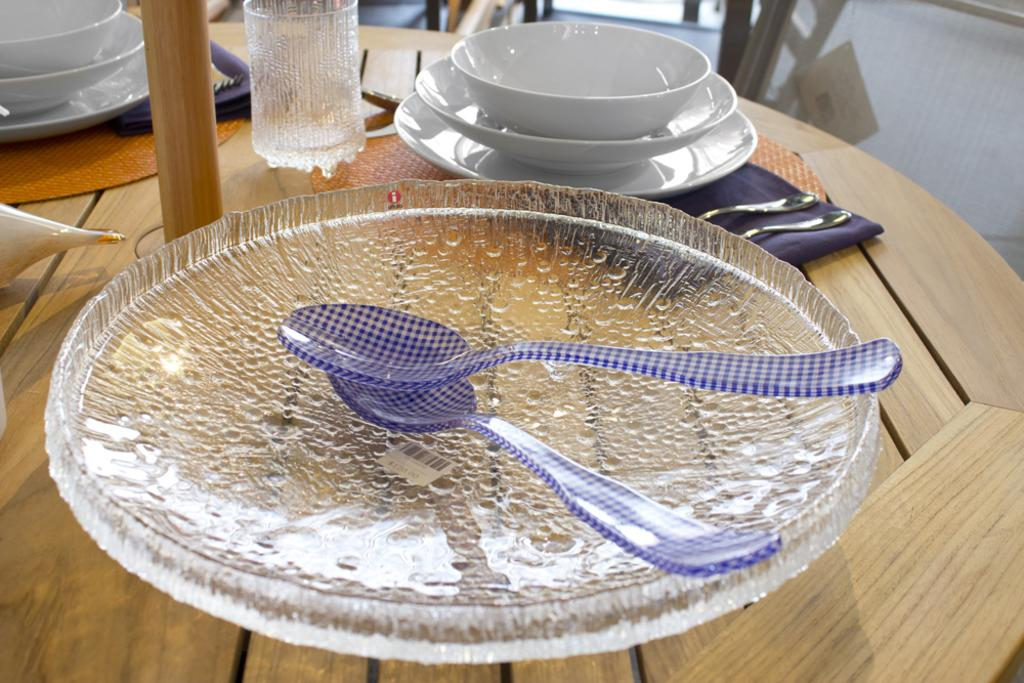What type of furniture is in the image? There is a table in the image. What is on top of the table? On the table, there is a plate, spoons, bowls, cloths, and a glass. What else can be found on the table? There is also a wooden stick on the table. Are there any objects visible in the background of the image? Yes, there are objects in the background of the image. What type of jeans is visible on the table in the image? There are no jeans present on the table in the image. Can you see a car in the background of the image? There is no car visible in the background of the image. 